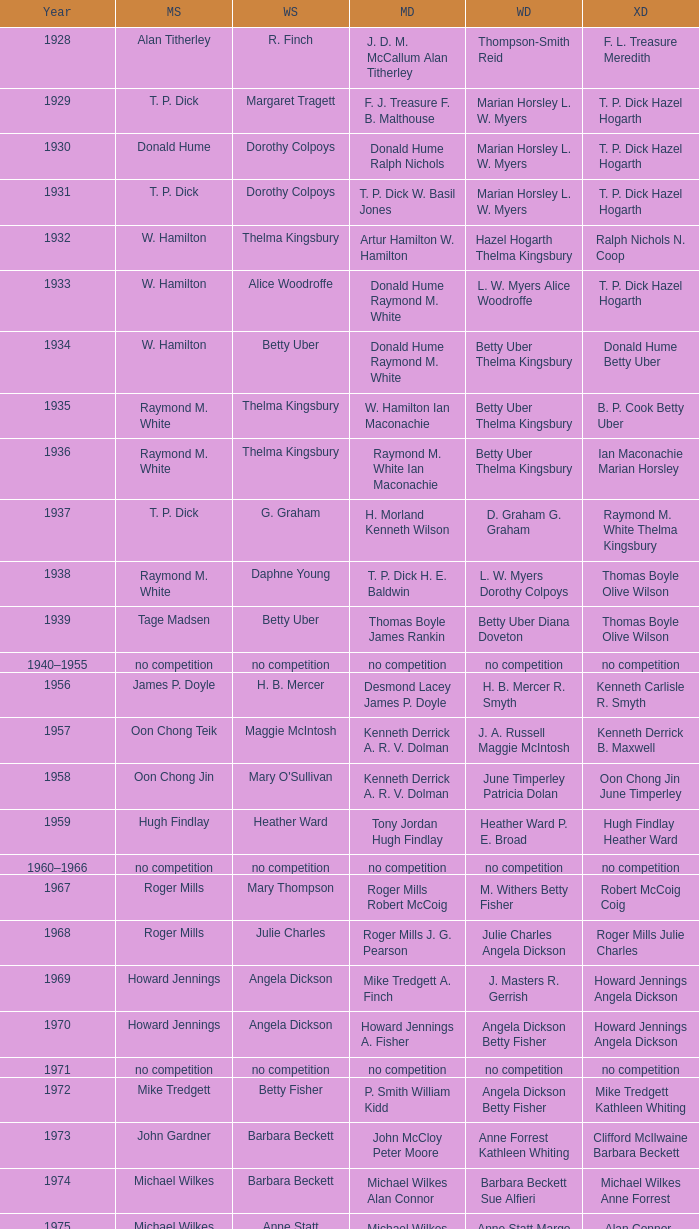When raymond m. white conquered the men's singles and w. hamilton ian maconachie claimed the men's doubles, who succeeded in winning the women's singles? Thelma Kingsbury. 